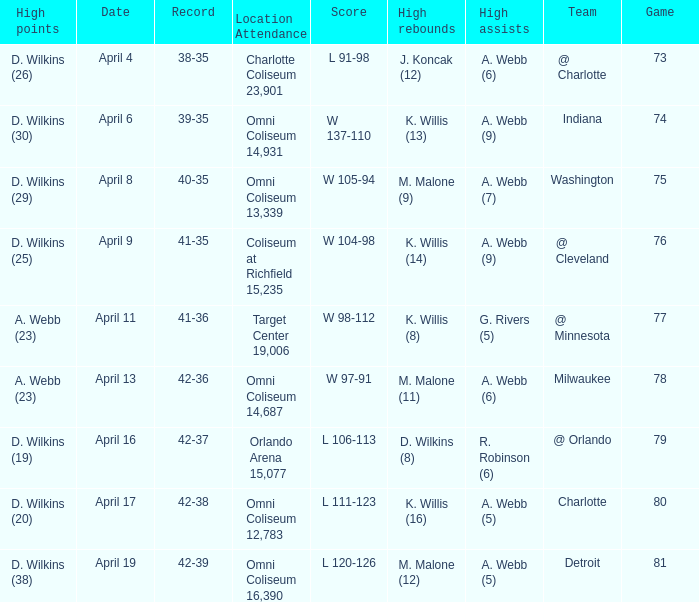Where was the location and attendance when they played milwaukee? Omni Coliseum 14,687. 